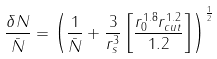<formula> <loc_0><loc_0><loc_500><loc_500>\frac { \delta N } { \bar { N } } = \left ( \frac { 1 } { \bar { N } } + \frac { 3 } { r _ { s } ^ { 3 } } \left [ \frac { r _ { 0 } ^ { 1 . 8 } r _ { c u t } ^ { 1 . 2 } } { 1 . 2 } \right ] \right ) ^ { \frac { 1 } { 2 } }</formula> 